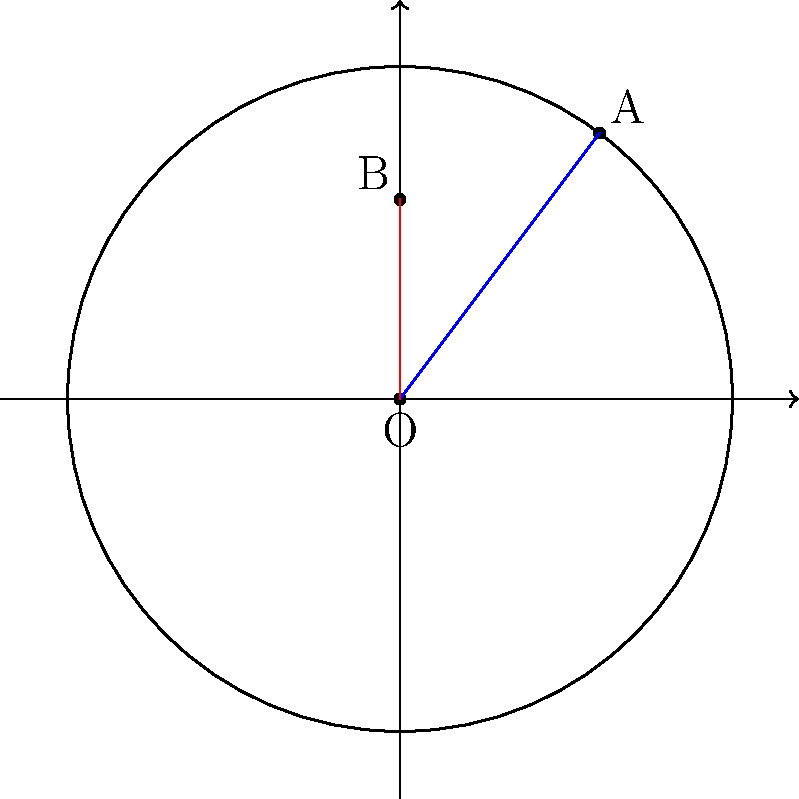Two rural health clinics, A and B, are located in different barangays of Talavera, Nueva Ecija. Using the municipal hall as the origin, clinic A is located at coordinates $(3,4)$ and clinic B at $(0,3)$ in a polar coordinate system where distances are measured in kilometers. Calculate the distance between the two clinics. To find the distance between the two clinics, we can use the following steps:

1) First, convert the given coordinates to polar form:

   Clinic A: $(r_1, \theta_1)$ where $r_1 = \sqrt{3^2 + 4^2} = 5$ km, $\theta_1 = \tan^{-1}(\frac{4}{3})$
   Clinic B: $(r_2, \theta_2)$ where $r_2 = 3$ km, $\theta_2 = \frac{\pi}{2}$

2) Now, we can use the law of cosines to find the distance $d$ between the two points:

   $d^2 = r_1^2 + r_2^2 - 2r_1r_2\cos(\theta_2 - \theta_1)$

3) Substitute the values:

   $d^2 = 5^2 + 3^2 - 2(5)(3)\cos(\frac{\pi}{2} - \tan^{-1}(\frac{4}{3}))$

4) Simplify:

   $d^2 = 25 + 9 - 30\cos(\frac{\pi}{2} - \tan^{-1}(\frac{4}{3}))$

5) Calculate the angle:

   $\frac{\pi}{2} - \tan^{-1}(\frac{4}{3}) \approx 0.6435$ radians

6) Solve:

   $d^2 = 34 - 30\cos(0.6435) \approx 34 - 30(0.8011) = 9.967$

7) Take the square root:

   $d = \sqrt{9.967} \approx 3.157$ km

Therefore, the distance between the two clinics is approximately 3.157 km.
Answer: $3.157$ km 